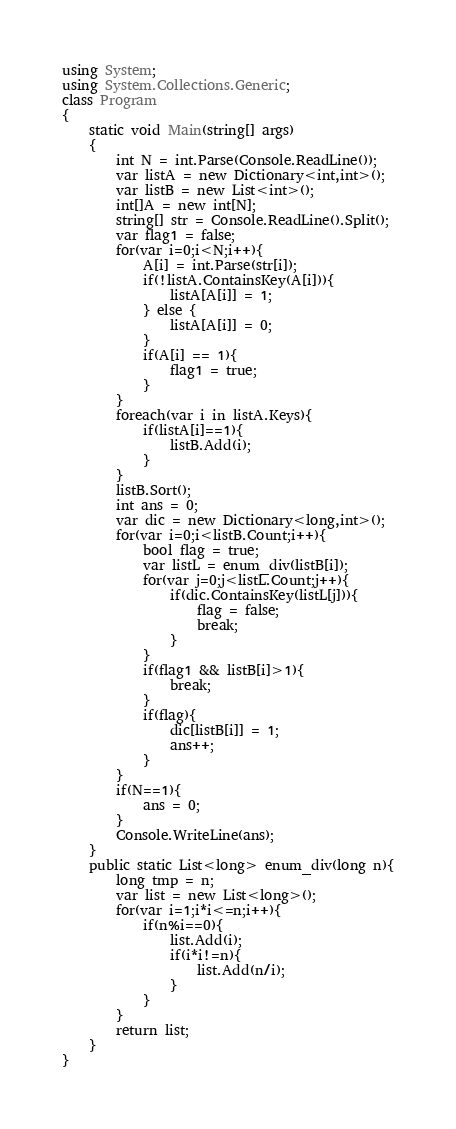<code> <loc_0><loc_0><loc_500><loc_500><_C#_>using System;
using System.Collections.Generic;
class Program
{
	static void Main(string[] args)
	{
		int N = int.Parse(Console.ReadLine());
		var listA = new Dictionary<int,int>();
		var listB = new List<int>();
		int[]A = new int[N];
		string[] str = Console.ReadLine().Split();
		var flag1 = false;
		for(var i=0;i<N;i++){
			A[i] = int.Parse(str[i]);
			if(!listA.ContainsKey(A[i])){
				listA[A[i]] = 1;
			} else {
				listA[A[i]] = 0;
			}
			if(A[i] == 1){
				flag1 = true;
			}
		}
		foreach(var i in listA.Keys){
			if(listA[i]==1){
				listB.Add(i);
			}
		}
		listB.Sort();
		int ans = 0;
		var dic = new Dictionary<long,int>();
		for(var i=0;i<listB.Count;i++){
			bool flag = true;
			var listL = enum_div(listB[i]);
			for(var j=0;j<listL.Count;j++){
				if(dic.ContainsKey(listL[j])){
					flag = false;
					break;
				}
			}
			if(flag1 && listB[i]>1){
				break;
			}
			if(flag){
				dic[listB[i]] = 1;
				ans++;
			}
		}
		if(N==1){
			ans = 0;
		}
		Console.WriteLine(ans);
	}
	public static List<long> enum_div(long n){
		long tmp = n;
		var list = new List<long>();
		for(var i=1;i*i<=n;i++){
			if(n%i==0){
				list.Add(i);
				if(i*i!=n){
					list.Add(n/i);
				}
			}
		}
		return list;
	}
}</code> 